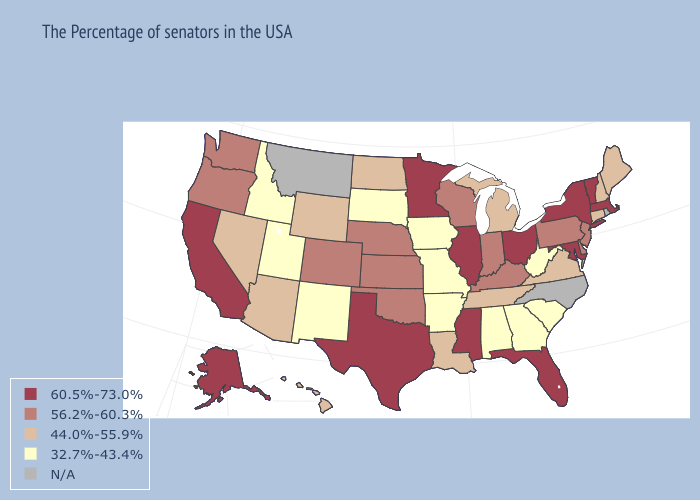Name the states that have a value in the range 56.2%-60.3%?
Short answer required. New Jersey, Delaware, Pennsylvania, Kentucky, Indiana, Wisconsin, Kansas, Nebraska, Oklahoma, Colorado, Washington, Oregon. Name the states that have a value in the range 32.7%-43.4%?
Short answer required. South Carolina, West Virginia, Georgia, Alabama, Missouri, Arkansas, Iowa, South Dakota, New Mexico, Utah, Idaho. Name the states that have a value in the range N/A?
Give a very brief answer. Rhode Island, North Carolina, Montana. Does the map have missing data?
Short answer required. Yes. Name the states that have a value in the range 32.7%-43.4%?
Be succinct. South Carolina, West Virginia, Georgia, Alabama, Missouri, Arkansas, Iowa, South Dakota, New Mexico, Utah, Idaho. What is the lowest value in states that border Arkansas?
Short answer required. 32.7%-43.4%. What is the lowest value in states that border Oregon?
Answer briefly. 32.7%-43.4%. Among the states that border New Jersey , which have the lowest value?
Be succinct. Delaware, Pennsylvania. Name the states that have a value in the range 56.2%-60.3%?
Write a very short answer. New Jersey, Delaware, Pennsylvania, Kentucky, Indiana, Wisconsin, Kansas, Nebraska, Oklahoma, Colorado, Washington, Oregon. What is the highest value in states that border Delaware?
Concise answer only. 60.5%-73.0%. What is the value of Nebraska?
Short answer required. 56.2%-60.3%. Name the states that have a value in the range N/A?
Answer briefly. Rhode Island, North Carolina, Montana. Name the states that have a value in the range 60.5%-73.0%?
Be succinct. Massachusetts, Vermont, New York, Maryland, Ohio, Florida, Illinois, Mississippi, Minnesota, Texas, California, Alaska. 